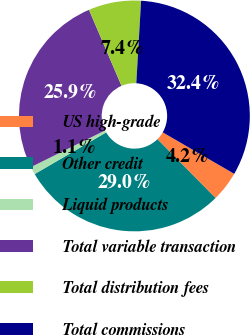<chart> <loc_0><loc_0><loc_500><loc_500><pie_chart><fcel>US high-grade<fcel>Other credit<fcel>Liquid products<fcel>Total variable transaction<fcel>Total distribution fees<fcel>Total commissions<nl><fcel>4.23%<fcel>29.0%<fcel>1.09%<fcel>25.87%<fcel>7.36%<fcel>32.44%<nl></chart> 